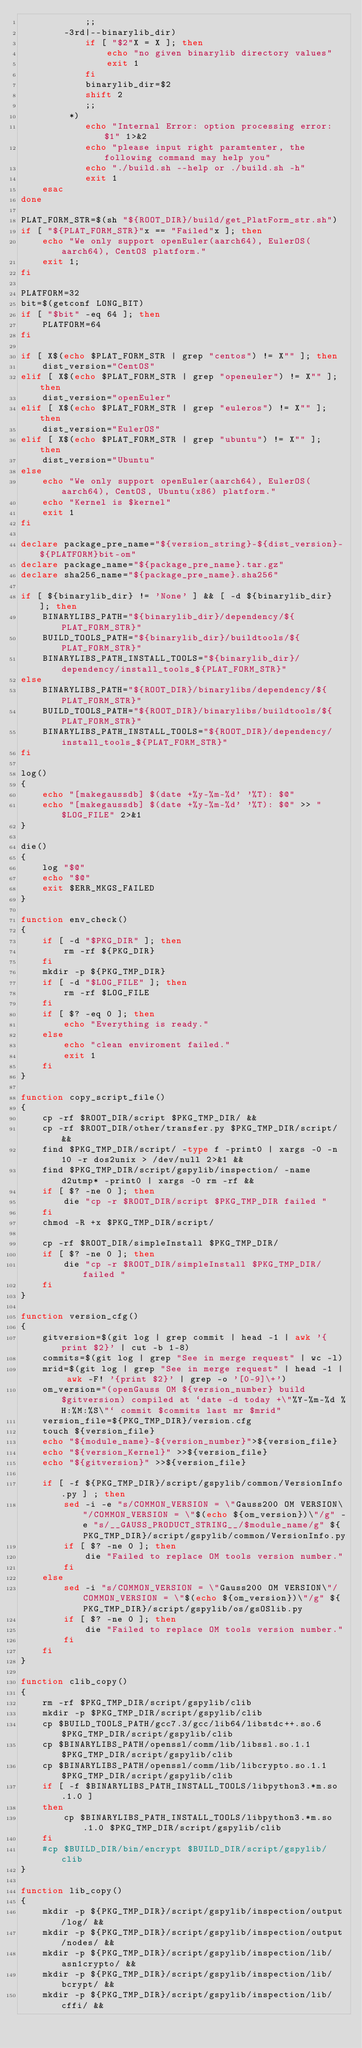<code> <loc_0><loc_0><loc_500><loc_500><_Bash_>            ;;
        -3rd|--binarylib_dir)
            if [ "$2"X = X ]; then
                echo "no given binarylib directory values"
                exit 1
            fi
            binarylib_dir=$2
            shift 2
            ;;
         *)
            echo "Internal Error: option processing error: $1" 1>&2
            echo "please input right paramtenter, the following command may help you"
            echo "./build.sh --help or ./build.sh -h"
            exit 1
    esac
done

PLAT_FORM_STR=$(sh "${ROOT_DIR}/build/get_PlatForm_str.sh")
if [ "${PLAT_FORM_STR}"x == "Failed"x ]; then
    echo "We only support openEuler(aarch64), EulerOS(aarch64), CentOS platform."
    exit 1;
fi

PLATFORM=32
bit=$(getconf LONG_BIT)
if [ "$bit" -eq 64 ]; then
    PLATFORM=64
fi

if [ X$(echo $PLAT_FORM_STR | grep "centos") != X"" ]; then
    dist_version="CentOS"
elif [ X$(echo $PLAT_FORM_STR | grep "openeuler") != X"" ]; then
    dist_version="openEuler"
elif [ X$(echo $PLAT_FORM_STR | grep "euleros") != X"" ]; then
    dist_version="EulerOS"
elif [ X$(echo $PLAT_FORM_STR | grep "ubuntu") != X"" ]; then
    dist_version="Ubuntu"
else
    echo "We only support openEuler(aarch64), EulerOS(aarch64), CentOS, Ubuntu(x86) platform."
    echo "Kernel is $kernel"
    exit 1
fi

declare package_pre_name="${version_string}-${dist_version}-${PLATFORM}bit-om"
declare package_name="${package_pre_name}.tar.gz"
declare sha256_name="${package_pre_name}.sha256"

if [ ${binarylib_dir} != 'None' ] && [ -d ${binarylib_dir} ]; then
    BINARYLIBS_PATH="${binarylib_dir}/dependency/${PLAT_FORM_STR}"
    BUILD_TOOLS_PATH="${binarylib_dir}/buildtools/${PLAT_FORM_STR}"
    BINARYLIBS_PATH_INSTALL_TOOLS="${binarylib_dir}/dependency/install_tools_${PLAT_FORM_STR}"
else
    BINARYLIBS_PATH="${ROOT_DIR}/binarylibs/dependency/${PLAT_FORM_STR}"
    BUILD_TOOLS_PATH="${ROOT_DIR}/binarylibs/buildtools/${PLAT_FORM_STR}"
    BINARYLIBS_PATH_INSTALL_TOOLS="${ROOT_DIR}/dependency/install_tools_${PLAT_FORM_STR}"	
fi

log()
{
    echo "[makegaussdb] $(date +%y-%m-%d' '%T): $@"
    echo "[makegaussdb] $(date +%y-%m-%d' '%T): $@" >> "$LOG_FILE" 2>&1
}

die()
{
    log "$@"
    echo "$@"
    exit $ERR_MKGS_FAILED
}

function env_check()
{
    if [ -d "$PKG_DIR" ]; then
        rm -rf ${PKG_DIR}
    fi
    mkdir -p ${PKG_TMP_DIR}
    if [ -d "$LOG_FILE" ]; then
        rm -rf $LOG_FILE
    fi
    if [ $? -eq 0 ]; then
        echo "Everything is ready."
    else
        echo "clean enviroment failed."
        exit 1
    fi
}

function copy_script_file()
{    
    cp -rf $ROOT_DIR/script $PKG_TMP_DIR/ &&
    cp -rf $ROOT_DIR/other/transfer.py $PKG_TMP_DIR/script/ &&
    find $PKG_TMP_DIR/script/ -type f -print0 | xargs -0 -n 10 -r dos2unix > /dev/null 2>&1 &&
    find $PKG_TMP_DIR/script/gspylib/inspection/ -name d2utmp* -print0 | xargs -0 rm -rf &&
    if [ $? -ne 0 ]; then
        die "cp -r $ROOT_DIR/script $PKG_TMP_DIR failed "
    fi
    chmod -R +x $PKG_TMP_DIR/script/
    
    cp -rf $ROOT_DIR/simpleInstall $PKG_TMP_DIR/
    if [ $? -ne 0 ]; then
        die "cp -r $ROOT_DIR/simpleInstall $PKG_TMP_DIR/ failed "
    fi    
}

function version_cfg()
{
    gitversion=$(git log | grep commit | head -1 | awk '{print $2}' | cut -b 1-8)
    commits=$(git log | grep "See in merge request" | wc -l)
    mrid=$(git log | grep "See in merge request" | head -1 | awk -F! '{print $2}' | grep -o '[0-9]\+')
    om_version="(openGauss OM ${version_number} build $gitversion) compiled at `date -d today +\"%Y-%m-%d %H:%M:%S\"` commit $commits last mr $mrid"
    version_file=${PKG_TMP_DIR}/version.cfg
    touch ${version_file}
    echo "${module_name}-${version_number}">${version_file}
    echo "${version_Kernel}" >>${version_file}
    echo "${gitversion}" >>${version_file}

    if [ -f ${PKG_TMP_DIR}/script/gspylib/common/VersionInfo.py ] ; then
        sed -i -e "s/COMMON_VERSION = \"Gauss200 OM VERSION\"/COMMON_VERSION = \"$(echo ${om_version})\"/g" -e "s/__GAUSS_PRODUCT_STRING__/$module_name/g" ${PKG_TMP_DIR}/script/gspylib/common/VersionInfo.py
        if [ $? -ne 0 ]; then
            die "Failed to replace OM tools version number."
        fi
    else
        sed -i "s/COMMON_VERSION = \"Gauss200 OM VERSION\"/COMMON_VERSION = \"$(echo ${om_version})\"/g" ${PKG_TMP_DIR}/script/gspylib/os/gsOSlib.py
        if [ $? -ne 0 ]; then
            die "Failed to replace OM tools version number."
        fi
    fi
}

function clib_copy()
{
    rm -rf $PKG_TMP_DIR/script/gspylib/clib
    mkdir -p $PKG_TMP_DIR/script/gspylib/clib
    cp $BUILD_TOOLS_PATH/gcc7.3/gcc/lib64/libstdc++.so.6 $PKG_TMP_DIR/script/gspylib/clib
    cp $BINARYLIBS_PATH/openssl/comm/lib/libssl.so.1.1 $PKG_TMP_DIR/script/gspylib/clib
    cp $BINARYLIBS_PATH/openssl/comm/lib/libcrypto.so.1.1 $PKG_TMP_DIR/script/gspylib/clib
    if [ -f $BINARYLIBS_PATH_INSTALL_TOOLS/libpython3.*m.so.1.0 ]
    then
        cp $BINARYLIBS_PATH_INSTALL_TOOLS/libpython3.*m.so.1.0 $PKG_TMP_DIR/script/gspylib/clib
    fi		
    #cp $BUILD_DIR/bin/encrypt $BUILD_DIR/script/gspylib/clib
}

function lib_copy()
{
    mkdir -p ${PKG_TMP_DIR}/script/gspylib/inspection/output/log/ &&
    mkdir -p ${PKG_TMP_DIR}/script/gspylib/inspection/output/nodes/ &&
    mkdir -p ${PKG_TMP_DIR}/script/gspylib/inspection/lib/asn1crypto/ &&
    mkdir -p ${PKG_TMP_DIR}/script/gspylib/inspection/lib/bcrypt/ &&
    mkdir -p ${PKG_TMP_DIR}/script/gspylib/inspection/lib/cffi/ &&</code> 